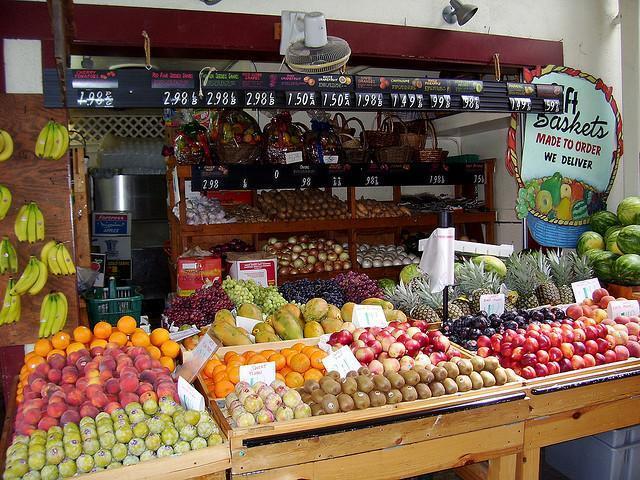How many apples are visible?
Give a very brief answer. 3. How many oranges are in the picture?
Give a very brief answer. 2. 